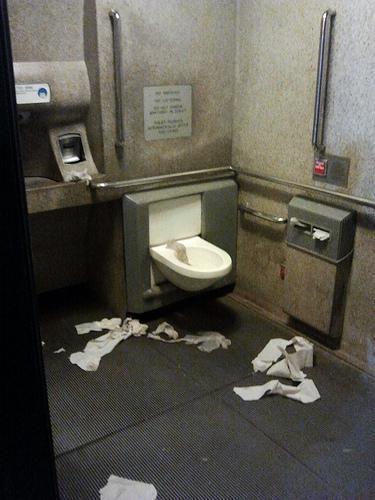How many toilets?
Give a very brief answer. 1. 